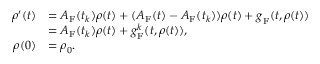<formula> <loc_0><loc_0><loc_500><loc_500>\begin{array} { r l } { \boldsymbol \rho ^ { \prime } ( t ) } & { = A _ { F } ( t _ { k } ) \boldsymbol \rho ( t ) + ( A _ { F } ( t ) - A _ { F } ( t _ { k } ) ) \boldsymbol \rho ( t ) + \boldsymbol g _ { F } ( t , \boldsymbol \rho ( t ) ) } \\ & { = A _ { F } ( t _ { k } ) \boldsymbol \rho ( t ) + \boldsymbol g _ { F } ^ { k } ( t , \boldsymbol \rho ( t ) ) , } \\ { \boldsymbol \rho ( 0 ) } & { = \boldsymbol \rho _ { 0 } . } \end{array}</formula> 